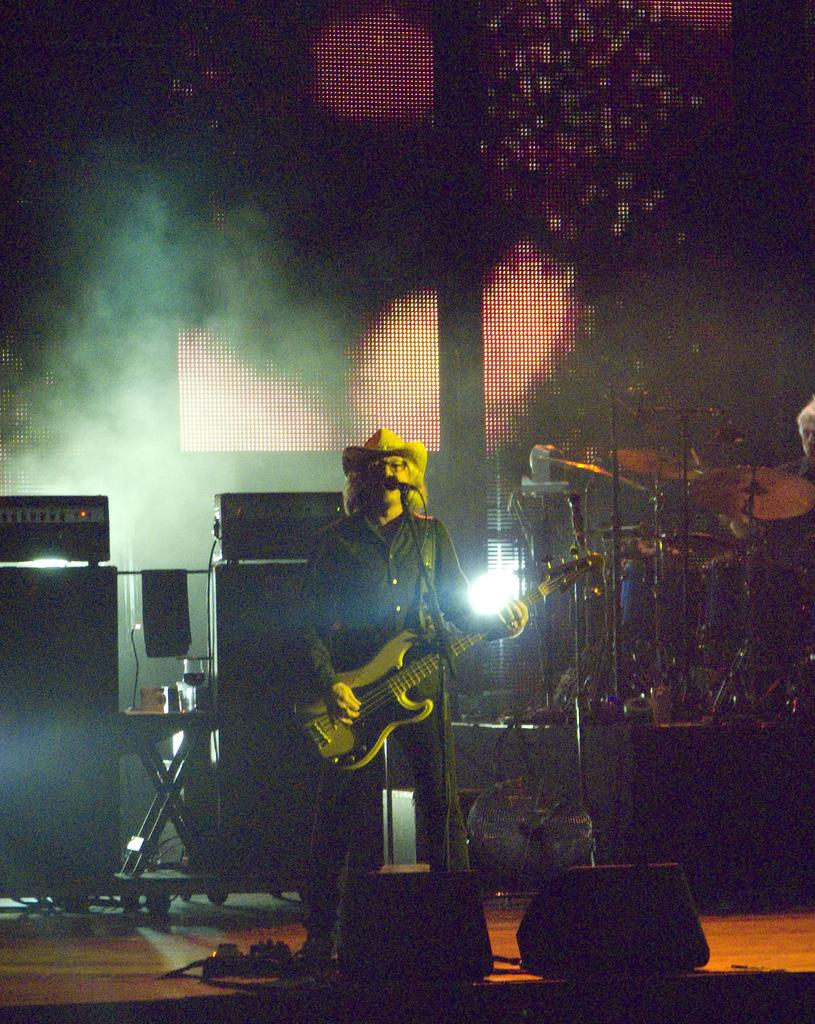What is the man in the image wearing? The man in the image is wearing a black jacket. What is the man doing in the image? The man is playing a guitar. What is the man positioned in front of in the image? The man is in front of a microphone. What other musical items can be seen in the image? There are musical instruments in the image. What type of electronic devices are present in the image? There are electronic devices in the image. What type of square is the man standing on in the image? There is no square present in the image; the man is standing in front of a microphone. Who is the coach in the image? There is no coach present in the image. 